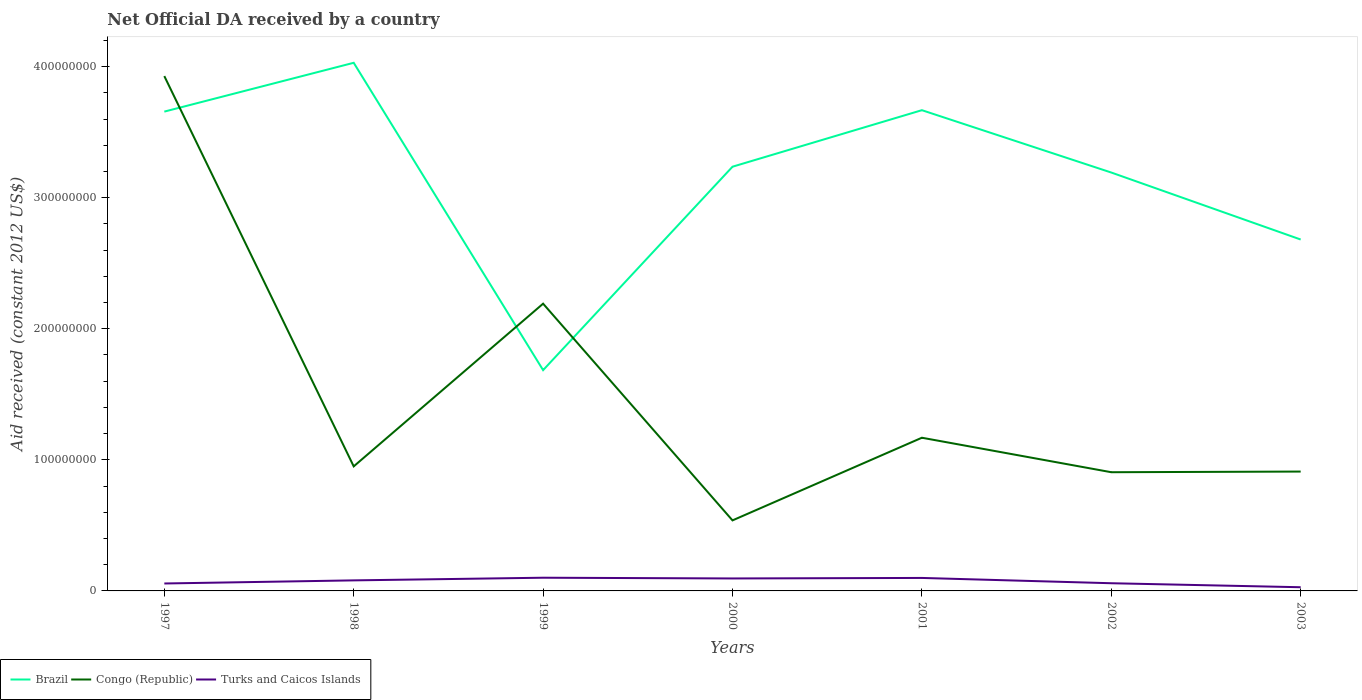How many different coloured lines are there?
Your answer should be compact. 3. Does the line corresponding to Brazil intersect with the line corresponding to Congo (Republic)?
Offer a terse response. Yes. Across all years, what is the maximum net official development assistance aid received in Brazil?
Make the answer very short. 1.68e+08. In which year was the net official development assistance aid received in Congo (Republic) maximum?
Provide a short and direct response. 2000. What is the total net official development assistance aid received in Brazil in the graph?
Keep it short and to the point. 4.65e+07. What is the difference between the highest and the second highest net official development assistance aid received in Brazil?
Offer a very short reply. 2.34e+08. What is the difference between the highest and the lowest net official development assistance aid received in Turks and Caicos Islands?
Offer a terse response. 4. Is the net official development assistance aid received in Congo (Republic) strictly greater than the net official development assistance aid received in Brazil over the years?
Provide a short and direct response. No. How many years are there in the graph?
Provide a short and direct response. 7. How many legend labels are there?
Provide a short and direct response. 3. How are the legend labels stacked?
Your response must be concise. Horizontal. What is the title of the graph?
Your answer should be compact. Net Official DA received by a country. What is the label or title of the Y-axis?
Make the answer very short. Aid received (constant 2012 US$). What is the Aid received (constant 2012 US$) in Brazil in 1997?
Provide a short and direct response. 3.66e+08. What is the Aid received (constant 2012 US$) of Congo (Republic) in 1997?
Give a very brief answer. 3.93e+08. What is the Aid received (constant 2012 US$) in Turks and Caicos Islands in 1997?
Provide a short and direct response. 5.67e+06. What is the Aid received (constant 2012 US$) of Brazil in 1998?
Provide a succinct answer. 4.03e+08. What is the Aid received (constant 2012 US$) in Congo (Republic) in 1998?
Your response must be concise. 9.50e+07. What is the Aid received (constant 2012 US$) in Turks and Caicos Islands in 1998?
Provide a short and direct response. 8.05e+06. What is the Aid received (constant 2012 US$) in Brazil in 1999?
Your answer should be very brief. 1.68e+08. What is the Aid received (constant 2012 US$) of Congo (Republic) in 1999?
Provide a succinct answer. 2.19e+08. What is the Aid received (constant 2012 US$) of Turks and Caicos Islands in 1999?
Offer a very short reply. 1.01e+07. What is the Aid received (constant 2012 US$) in Brazil in 2000?
Give a very brief answer. 3.24e+08. What is the Aid received (constant 2012 US$) of Congo (Republic) in 2000?
Ensure brevity in your answer.  5.38e+07. What is the Aid received (constant 2012 US$) of Turks and Caicos Islands in 2000?
Offer a very short reply. 9.51e+06. What is the Aid received (constant 2012 US$) in Brazil in 2001?
Provide a short and direct response. 3.67e+08. What is the Aid received (constant 2012 US$) in Congo (Republic) in 2001?
Your answer should be very brief. 1.17e+08. What is the Aid received (constant 2012 US$) of Turks and Caicos Islands in 2001?
Your response must be concise. 9.91e+06. What is the Aid received (constant 2012 US$) of Brazil in 2002?
Provide a short and direct response. 3.19e+08. What is the Aid received (constant 2012 US$) of Congo (Republic) in 2002?
Give a very brief answer. 9.06e+07. What is the Aid received (constant 2012 US$) of Turks and Caicos Islands in 2002?
Your answer should be very brief. 5.86e+06. What is the Aid received (constant 2012 US$) of Brazil in 2003?
Your answer should be compact. 2.68e+08. What is the Aid received (constant 2012 US$) in Congo (Republic) in 2003?
Make the answer very short. 9.11e+07. What is the Aid received (constant 2012 US$) of Turks and Caicos Islands in 2003?
Offer a terse response. 2.81e+06. Across all years, what is the maximum Aid received (constant 2012 US$) of Brazil?
Offer a terse response. 4.03e+08. Across all years, what is the maximum Aid received (constant 2012 US$) in Congo (Republic)?
Offer a terse response. 3.93e+08. Across all years, what is the maximum Aid received (constant 2012 US$) in Turks and Caicos Islands?
Make the answer very short. 1.01e+07. Across all years, what is the minimum Aid received (constant 2012 US$) of Brazil?
Your answer should be very brief. 1.68e+08. Across all years, what is the minimum Aid received (constant 2012 US$) of Congo (Republic)?
Your response must be concise. 5.38e+07. Across all years, what is the minimum Aid received (constant 2012 US$) in Turks and Caicos Islands?
Keep it short and to the point. 2.81e+06. What is the total Aid received (constant 2012 US$) in Brazil in the graph?
Offer a terse response. 2.21e+09. What is the total Aid received (constant 2012 US$) of Congo (Republic) in the graph?
Your answer should be compact. 1.06e+09. What is the total Aid received (constant 2012 US$) of Turks and Caicos Islands in the graph?
Offer a terse response. 5.19e+07. What is the difference between the Aid received (constant 2012 US$) in Brazil in 1997 and that in 1998?
Your answer should be compact. -3.72e+07. What is the difference between the Aid received (constant 2012 US$) in Congo (Republic) in 1997 and that in 1998?
Give a very brief answer. 2.98e+08. What is the difference between the Aid received (constant 2012 US$) in Turks and Caicos Islands in 1997 and that in 1998?
Your answer should be very brief. -2.38e+06. What is the difference between the Aid received (constant 2012 US$) of Brazil in 1997 and that in 1999?
Keep it short and to the point. 1.97e+08. What is the difference between the Aid received (constant 2012 US$) of Congo (Republic) in 1997 and that in 1999?
Your answer should be compact. 1.74e+08. What is the difference between the Aid received (constant 2012 US$) in Turks and Caicos Islands in 1997 and that in 1999?
Your response must be concise. -4.40e+06. What is the difference between the Aid received (constant 2012 US$) of Brazil in 1997 and that in 2000?
Ensure brevity in your answer.  4.20e+07. What is the difference between the Aid received (constant 2012 US$) of Congo (Republic) in 1997 and that in 2000?
Ensure brevity in your answer.  3.39e+08. What is the difference between the Aid received (constant 2012 US$) in Turks and Caicos Islands in 1997 and that in 2000?
Offer a terse response. -3.84e+06. What is the difference between the Aid received (constant 2012 US$) in Brazil in 1997 and that in 2001?
Provide a short and direct response. -1.09e+06. What is the difference between the Aid received (constant 2012 US$) in Congo (Republic) in 1997 and that in 2001?
Provide a succinct answer. 2.76e+08. What is the difference between the Aid received (constant 2012 US$) of Turks and Caicos Islands in 1997 and that in 2001?
Provide a succinct answer. -4.24e+06. What is the difference between the Aid received (constant 2012 US$) of Brazil in 1997 and that in 2002?
Your answer should be very brief. 4.65e+07. What is the difference between the Aid received (constant 2012 US$) in Congo (Republic) in 1997 and that in 2002?
Give a very brief answer. 3.02e+08. What is the difference between the Aid received (constant 2012 US$) of Turks and Caicos Islands in 1997 and that in 2002?
Provide a short and direct response. -1.90e+05. What is the difference between the Aid received (constant 2012 US$) in Brazil in 1997 and that in 2003?
Offer a very short reply. 9.76e+07. What is the difference between the Aid received (constant 2012 US$) in Congo (Republic) in 1997 and that in 2003?
Provide a succinct answer. 3.02e+08. What is the difference between the Aid received (constant 2012 US$) in Turks and Caicos Islands in 1997 and that in 2003?
Give a very brief answer. 2.86e+06. What is the difference between the Aid received (constant 2012 US$) of Brazil in 1998 and that in 1999?
Offer a terse response. 2.34e+08. What is the difference between the Aid received (constant 2012 US$) of Congo (Republic) in 1998 and that in 1999?
Provide a succinct answer. -1.24e+08. What is the difference between the Aid received (constant 2012 US$) of Turks and Caicos Islands in 1998 and that in 1999?
Ensure brevity in your answer.  -2.02e+06. What is the difference between the Aid received (constant 2012 US$) in Brazil in 1998 and that in 2000?
Your answer should be very brief. 7.93e+07. What is the difference between the Aid received (constant 2012 US$) in Congo (Republic) in 1998 and that in 2000?
Your response must be concise. 4.12e+07. What is the difference between the Aid received (constant 2012 US$) in Turks and Caicos Islands in 1998 and that in 2000?
Your answer should be compact. -1.46e+06. What is the difference between the Aid received (constant 2012 US$) in Brazil in 1998 and that in 2001?
Provide a short and direct response. 3.62e+07. What is the difference between the Aid received (constant 2012 US$) in Congo (Republic) in 1998 and that in 2001?
Make the answer very short. -2.18e+07. What is the difference between the Aid received (constant 2012 US$) in Turks and Caicos Islands in 1998 and that in 2001?
Your answer should be compact. -1.86e+06. What is the difference between the Aid received (constant 2012 US$) in Brazil in 1998 and that in 2002?
Offer a terse response. 8.37e+07. What is the difference between the Aid received (constant 2012 US$) in Congo (Republic) in 1998 and that in 2002?
Keep it short and to the point. 4.46e+06. What is the difference between the Aid received (constant 2012 US$) in Turks and Caicos Islands in 1998 and that in 2002?
Offer a very short reply. 2.19e+06. What is the difference between the Aid received (constant 2012 US$) of Brazil in 1998 and that in 2003?
Make the answer very short. 1.35e+08. What is the difference between the Aid received (constant 2012 US$) of Congo (Republic) in 1998 and that in 2003?
Keep it short and to the point. 3.96e+06. What is the difference between the Aid received (constant 2012 US$) of Turks and Caicos Islands in 1998 and that in 2003?
Your response must be concise. 5.24e+06. What is the difference between the Aid received (constant 2012 US$) of Brazil in 1999 and that in 2000?
Keep it short and to the point. -1.55e+08. What is the difference between the Aid received (constant 2012 US$) in Congo (Republic) in 1999 and that in 2000?
Offer a very short reply. 1.65e+08. What is the difference between the Aid received (constant 2012 US$) of Turks and Caicos Islands in 1999 and that in 2000?
Give a very brief answer. 5.60e+05. What is the difference between the Aid received (constant 2012 US$) in Brazil in 1999 and that in 2001?
Your answer should be very brief. -1.98e+08. What is the difference between the Aid received (constant 2012 US$) in Congo (Republic) in 1999 and that in 2001?
Your response must be concise. 1.02e+08. What is the difference between the Aid received (constant 2012 US$) in Turks and Caicos Islands in 1999 and that in 2001?
Give a very brief answer. 1.60e+05. What is the difference between the Aid received (constant 2012 US$) of Brazil in 1999 and that in 2002?
Keep it short and to the point. -1.51e+08. What is the difference between the Aid received (constant 2012 US$) in Congo (Republic) in 1999 and that in 2002?
Give a very brief answer. 1.29e+08. What is the difference between the Aid received (constant 2012 US$) in Turks and Caicos Islands in 1999 and that in 2002?
Give a very brief answer. 4.21e+06. What is the difference between the Aid received (constant 2012 US$) of Brazil in 1999 and that in 2003?
Your response must be concise. -9.97e+07. What is the difference between the Aid received (constant 2012 US$) of Congo (Republic) in 1999 and that in 2003?
Make the answer very short. 1.28e+08. What is the difference between the Aid received (constant 2012 US$) of Turks and Caicos Islands in 1999 and that in 2003?
Provide a short and direct response. 7.26e+06. What is the difference between the Aid received (constant 2012 US$) of Brazil in 2000 and that in 2001?
Ensure brevity in your answer.  -4.31e+07. What is the difference between the Aid received (constant 2012 US$) of Congo (Republic) in 2000 and that in 2001?
Offer a very short reply. -6.31e+07. What is the difference between the Aid received (constant 2012 US$) in Turks and Caicos Islands in 2000 and that in 2001?
Offer a very short reply. -4.00e+05. What is the difference between the Aid received (constant 2012 US$) in Brazil in 2000 and that in 2002?
Provide a succinct answer. 4.44e+06. What is the difference between the Aid received (constant 2012 US$) in Congo (Republic) in 2000 and that in 2002?
Keep it short and to the point. -3.68e+07. What is the difference between the Aid received (constant 2012 US$) of Turks and Caicos Islands in 2000 and that in 2002?
Offer a terse response. 3.65e+06. What is the difference between the Aid received (constant 2012 US$) in Brazil in 2000 and that in 2003?
Ensure brevity in your answer.  5.56e+07. What is the difference between the Aid received (constant 2012 US$) in Congo (Republic) in 2000 and that in 2003?
Provide a succinct answer. -3.72e+07. What is the difference between the Aid received (constant 2012 US$) in Turks and Caicos Islands in 2000 and that in 2003?
Ensure brevity in your answer.  6.70e+06. What is the difference between the Aid received (constant 2012 US$) of Brazil in 2001 and that in 2002?
Offer a terse response. 4.76e+07. What is the difference between the Aid received (constant 2012 US$) of Congo (Republic) in 2001 and that in 2002?
Your response must be concise. 2.63e+07. What is the difference between the Aid received (constant 2012 US$) of Turks and Caicos Islands in 2001 and that in 2002?
Make the answer very short. 4.05e+06. What is the difference between the Aid received (constant 2012 US$) of Brazil in 2001 and that in 2003?
Provide a succinct answer. 9.87e+07. What is the difference between the Aid received (constant 2012 US$) of Congo (Republic) in 2001 and that in 2003?
Provide a succinct answer. 2.58e+07. What is the difference between the Aid received (constant 2012 US$) of Turks and Caicos Islands in 2001 and that in 2003?
Your response must be concise. 7.10e+06. What is the difference between the Aid received (constant 2012 US$) in Brazil in 2002 and that in 2003?
Provide a short and direct response. 5.11e+07. What is the difference between the Aid received (constant 2012 US$) of Congo (Republic) in 2002 and that in 2003?
Offer a terse response. -5.00e+05. What is the difference between the Aid received (constant 2012 US$) in Turks and Caicos Islands in 2002 and that in 2003?
Make the answer very short. 3.05e+06. What is the difference between the Aid received (constant 2012 US$) in Brazil in 1997 and the Aid received (constant 2012 US$) in Congo (Republic) in 1998?
Your answer should be compact. 2.71e+08. What is the difference between the Aid received (constant 2012 US$) of Brazil in 1997 and the Aid received (constant 2012 US$) of Turks and Caicos Islands in 1998?
Offer a very short reply. 3.58e+08. What is the difference between the Aid received (constant 2012 US$) in Congo (Republic) in 1997 and the Aid received (constant 2012 US$) in Turks and Caicos Islands in 1998?
Your answer should be compact. 3.85e+08. What is the difference between the Aid received (constant 2012 US$) of Brazil in 1997 and the Aid received (constant 2012 US$) of Congo (Republic) in 1999?
Offer a terse response. 1.47e+08. What is the difference between the Aid received (constant 2012 US$) of Brazil in 1997 and the Aid received (constant 2012 US$) of Turks and Caicos Islands in 1999?
Provide a succinct answer. 3.56e+08. What is the difference between the Aid received (constant 2012 US$) in Congo (Republic) in 1997 and the Aid received (constant 2012 US$) in Turks and Caicos Islands in 1999?
Ensure brevity in your answer.  3.83e+08. What is the difference between the Aid received (constant 2012 US$) of Brazil in 1997 and the Aid received (constant 2012 US$) of Congo (Republic) in 2000?
Offer a very short reply. 3.12e+08. What is the difference between the Aid received (constant 2012 US$) in Brazil in 1997 and the Aid received (constant 2012 US$) in Turks and Caicos Islands in 2000?
Offer a very short reply. 3.56e+08. What is the difference between the Aid received (constant 2012 US$) in Congo (Republic) in 1997 and the Aid received (constant 2012 US$) in Turks and Caicos Islands in 2000?
Your answer should be very brief. 3.83e+08. What is the difference between the Aid received (constant 2012 US$) in Brazil in 1997 and the Aid received (constant 2012 US$) in Congo (Republic) in 2001?
Provide a succinct answer. 2.49e+08. What is the difference between the Aid received (constant 2012 US$) of Brazil in 1997 and the Aid received (constant 2012 US$) of Turks and Caicos Islands in 2001?
Ensure brevity in your answer.  3.56e+08. What is the difference between the Aid received (constant 2012 US$) in Congo (Republic) in 1997 and the Aid received (constant 2012 US$) in Turks and Caicos Islands in 2001?
Your answer should be compact. 3.83e+08. What is the difference between the Aid received (constant 2012 US$) of Brazil in 1997 and the Aid received (constant 2012 US$) of Congo (Republic) in 2002?
Offer a terse response. 2.75e+08. What is the difference between the Aid received (constant 2012 US$) in Brazil in 1997 and the Aid received (constant 2012 US$) in Turks and Caicos Islands in 2002?
Make the answer very short. 3.60e+08. What is the difference between the Aid received (constant 2012 US$) in Congo (Republic) in 1997 and the Aid received (constant 2012 US$) in Turks and Caicos Islands in 2002?
Keep it short and to the point. 3.87e+08. What is the difference between the Aid received (constant 2012 US$) of Brazil in 1997 and the Aid received (constant 2012 US$) of Congo (Republic) in 2003?
Your answer should be compact. 2.75e+08. What is the difference between the Aid received (constant 2012 US$) of Brazil in 1997 and the Aid received (constant 2012 US$) of Turks and Caicos Islands in 2003?
Provide a short and direct response. 3.63e+08. What is the difference between the Aid received (constant 2012 US$) in Congo (Republic) in 1997 and the Aid received (constant 2012 US$) in Turks and Caicos Islands in 2003?
Make the answer very short. 3.90e+08. What is the difference between the Aid received (constant 2012 US$) of Brazil in 1998 and the Aid received (constant 2012 US$) of Congo (Republic) in 1999?
Your response must be concise. 1.84e+08. What is the difference between the Aid received (constant 2012 US$) in Brazil in 1998 and the Aid received (constant 2012 US$) in Turks and Caicos Islands in 1999?
Provide a short and direct response. 3.93e+08. What is the difference between the Aid received (constant 2012 US$) in Congo (Republic) in 1998 and the Aid received (constant 2012 US$) in Turks and Caicos Islands in 1999?
Ensure brevity in your answer.  8.50e+07. What is the difference between the Aid received (constant 2012 US$) of Brazil in 1998 and the Aid received (constant 2012 US$) of Congo (Republic) in 2000?
Your answer should be compact. 3.49e+08. What is the difference between the Aid received (constant 2012 US$) in Brazil in 1998 and the Aid received (constant 2012 US$) in Turks and Caicos Islands in 2000?
Your answer should be very brief. 3.93e+08. What is the difference between the Aid received (constant 2012 US$) in Congo (Republic) in 1998 and the Aid received (constant 2012 US$) in Turks and Caicos Islands in 2000?
Your response must be concise. 8.55e+07. What is the difference between the Aid received (constant 2012 US$) in Brazil in 1998 and the Aid received (constant 2012 US$) in Congo (Republic) in 2001?
Your answer should be very brief. 2.86e+08. What is the difference between the Aid received (constant 2012 US$) of Brazil in 1998 and the Aid received (constant 2012 US$) of Turks and Caicos Islands in 2001?
Your response must be concise. 3.93e+08. What is the difference between the Aid received (constant 2012 US$) in Congo (Republic) in 1998 and the Aid received (constant 2012 US$) in Turks and Caicos Islands in 2001?
Offer a terse response. 8.51e+07. What is the difference between the Aid received (constant 2012 US$) in Brazil in 1998 and the Aid received (constant 2012 US$) in Congo (Republic) in 2002?
Provide a short and direct response. 3.12e+08. What is the difference between the Aid received (constant 2012 US$) in Brazil in 1998 and the Aid received (constant 2012 US$) in Turks and Caicos Islands in 2002?
Offer a very short reply. 3.97e+08. What is the difference between the Aid received (constant 2012 US$) of Congo (Republic) in 1998 and the Aid received (constant 2012 US$) of Turks and Caicos Islands in 2002?
Provide a succinct answer. 8.92e+07. What is the difference between the Aid received (constant 2012 US$) of Brazil in 1998 and the Aid received (constant 2012 US$) of Congo (Republic) in 2003?
Give a very brief answer. 3.12e+08. What is the difference between the Aid received (constant 2012 US$) of Brazil in 1998 and the Aid received (constant 2012 US$) of Turks and Caicos Islands in 2003?
Your answer should be compact. 4.00e+08. What is the difference between the Aid received (constant 2012 US$) in Congo (Republic) in 1998 and the Aid received (constant 2012 US$) in Turks and Caicos Islands in 2003?
Your answer should be very brief. 9.22e+07. What is the difference between the Aid received (constant 2012 US$) in Brazil in 1999 and the Aid received (constant 2012 US$) in Congo (Republic) in 2000?
Offer a terse response. 1.15e+08. What is the difference between the Aid received (constant 2012 US$) in Brazil in 1999 and the Aid received (constant 2012 US$) in Turks and Caicos Islands in 2000?
Offer a terse response. 1.59e+08. What is the difference between the Aid received (constant 2012 US$) in Congo (Republic) in 1999 and the Aid received (constant 2012 US$) in Turks and Caicos Islands in 2000?
Provide a short and direct response. 2.10e+08. What is the difference between the Aid received (constant 2012 US$) of Brazil in 1999 and the Aid received (constant 2012 US$) of Congo (Republic) in 2001?
Provide a succinct answer. 5.16e+07. What is the difference between the Aid received (constant 2012 US$) of Brazil in 1999 and the Aid received (constant 2012 US$) of Turks and Caicos Islands in 2001?
Provide a succinct answer. 1.59e+08. What is the difference between the Aid received (constant 2012 US$) in Congo (Republic) in 1999 and the Aid received (constant 2012 US$) in Turks and Caicos Islands in 2001?
Give a very brief answer. 2.09e+08. What is the difference between the Aid received (constant 2012 US$) of Brazil in 1999 and the Aid received (constant 2012 US$) of Congo (Republic) in 2002?
Make the answer very short. 7.79e+07. What is the difference between the Aid received (constant 2012 US$) of Brazil in 1999 and the Aid received (constant 2012 US$) of Turks and Caicos Islands in 2002?
Provide a succinct answer. 1.63e+08. What is the difference between the Aid received (constant 2012 US$) in Congo (Republic) in 1999 and the Aid received (constant 2012 US$) in Turks and Caicos Islands in 2002?
Your answer should be very brief. 2.13e+08. What is the difference between the Aid received (constant 2012 US$) in Brazil in 1999 and the Aid received (constant 2012 US$) in Congo (Republic) in 2003?
Provide a succinct answer. 7.74e+07. What is the difference between the Aid received (constant 2012 US$) of Brazil in 1999 and the Aid received (constant 2012 US$) of Turks and Caicos Islands in 2003?
Keep it short and to the point. 1.66e+08. What is the difference between the Aid received (constant 2012 US$) of Congo (Republic) in 1999 and the Aid received (constant 2012 US$) of Turks and Caicos Islands in 2003?
Offer a very short reply. 2.16e+08. What is the difference between the Aid received (constant 2012 US$) of Brazil in 2000 and the Aid received (constant 2012 US$) of Congo (Republic) in 2001?
Offer a terse response. 2.07e+08. What is the difference between the Aid received (constant 2012 US$) of Brazil in 2000 and the Aid received (constant 2012 US$) of Turks and Caicos Islands in 2001?
Make the answer very short. 3.14e+08. What is the difference between the Aid received (constant 2012 US$) in Congo (Republic) in 2000 and the Aid received (constant 2012 US$) in Turks and Caicos Islands in 2001?
Keep it short and to the point. 4.39e+07. What is the difference between the Aid received (constant 2012 US$) in Brazil in 2000 and the Aid received (constant 2012 US$) in Congo (Republic) in 2002?
Your response must be concise. 2.33e+08. What is the difference between the Aid received (constant 2012 US$) in Brazil in 2000 and the Aid received (constant 2012 US$) in Turks and Caicos Islands in 2002?
Make the answer very short. 3.18e+08. What is the difference between the Aid received (constant 2012 US$) of Congo (Republic) in 2000 and the Aid received (constant 2012 US$) of Turks and Caicos Islands in 2002?
Give a very brief answer. 4.80e+07. What is the difference between the Aid received (constant 2012 US$) in Brazil in 2000 and the Aid received (constant 2012 US$) in Congo (Republic) in 2003?
Provide a succinct answer. 2.33e+08. What is the difference between the Aid received (constant 2012 US$) of Brazil in 2000 and the Aid received (constant 2012 US$) of Turks and Caicos Islands in 2003?
Offer a terse response. 3.21e+08. What is the difference between the Aid received (constant 2012 US$) of Congo (Republic) in 2000 and the Aid received (constant 2012 US$) of Turks and Caicos Islands in 2003?
Provide a short and direct response. 5.10e+07. What is the difference between the Aid received (constant 2012 US$) in Brazil in 2001 and the Aid received (constant 2012 US$) in Congo (Republic) in 2002?
Make the answer very short. 2.76e+08. What is the difference between the Aid received (constant 2012 US$) in Brazil in 2001 and the Aid received (constant 2012 US$) in Turks and Caicos Islands in 2002?
Provide a succinct answer. 3.61e+08. What is the difference between the Aid received (constant 2012 US$) in Congo (Republic) in 2001 and the Aid received (constant 2012 US$) in Turks and Caicos Islands in 2002?
Offer a very short reply. 1.11e+08. What is the difference between the Aid received (constant 2012 US$) in Brazil in 2001 and the Aid received (constant 2012 US$) in Congo (Republic) in 2003?
Offer a very short reply. 2.76e+08. What is the difference between the Aid received (constant 2012 US$) in Brazil in 2001 and the Aid received (constant 2012 US$) in Turks and Caicos Islands in 2003?
Offer a terse response. 3.64e+08. What is the difference between the Aid received (constant 2012 US$) in Congo (Republic) in 2001 and the Aid received (constant 2012 US$) in Turks and Caicos Islands in 2003?
Ensure brevity in your answer.  1.14e+08. What is the difference between the Aid received (constant 2012 US$) of Brazil in 2002 and the Aid received (constant 2012 US$) of Congo (Republic) in 2003?
Your answer should be compact. 2.28e+08. What is the difference between the Aid received (constant 2012 US$) of Brazil in 2002 and the Aid received (constant 2012 US$) of Turks and Caicos Islands in 2003?
Offer a very short reply. 3.16e+08. What is the difference between the Aid received (constant 2012 US$) of Congo (Republic) in 2002 and the Aid received (constant 2012 US$) of Turks and Caicos Islands in 2003?
Your answer should be very brief. 8.78e+07. What is the average Aid received (constant 2012 US$) in Brazil per year?
Keep it short and to the point. 3.16e+08. What is the average Aid received (constant 2012 US$) in Congo (Republic) per year?
Your answer should be very brief. 1.51e+08. What is the average Aid received (constant 2012 US$) in Turks and Caicos Islands per year?
Provide a succinct answer. 7.41e+06. In the year 1997, what is the difference between the Aid received (constant 2012 US$) in Brazil and Aid received (constant 2012 US$) in Congo (Republic)?
Your response must be concise. -2.71e+07. In the year 1997, what is the difference between the Aid received (constant 2012 US$) in Brazil and Aid received (constant 2012 US$) in Turks and Caicos Islands?
Give a very brief answer. 3.60e+08. In the year 1997, what is the difference between the Aid received (constant 2012 US$) in Congo (Republic) and Aid received (constant 2012 US$) in Turks and Caicos Islands?
Your answer should be very brief. 3.87e+08. In the year 1998, what is the difference between the Aid received (constant 2012 US$) in Brazil and Aid received (constant 2012 US$) in Congo (Republic)?
Provide a short and direct response. 3.08e+08. In the year 1998, what is the difference between the Aid received (constant 2012 US$) of Brazil and Aid received (constant 2012 US$) of Turks and Caicos Islands?
Ensure brevity in your answer.  3.95e+08. In the year 1998, what is the difference between the Aid received (constant 2012 US$) of Congo (Republic) and Aid received (constant 2012 US$) of Turks and Caicos Islands?
Offer a very short reply. 8.70e+07. In the year 1999, what is the difference between the Aid received (constant 2012 US$) of Brazil and Aid received (constant 2012 US$) of Congo (Republic)?
Your response must be concise. -5.07e+07. In the year 1999, what is the difference between the Aid received (constant 2012 US$) of Brazil and Aid received (constant 2012 US$) of Turks and Caicos Islands?
Your answer should be compact. 1.58e+08. In the year 1999, what is the difference between the Aid received (constant 2012 US$) in Congo (Republic) and Aid received (constant 2012 US$) in Turks and Caicos Islands?
Make the answer very short. 2.09e+08. In the year 2000, what is the difference between the Aid received (constant 2012 US$) of Brazil and Aid received (constant 2012 US$) of Congo (Republic)?
Your answer should be very brief. 2.70e+08. In the year 2000, what is the difference between the Aid received (constant 2012 US$) in Brazil and Aid received (constant 2012 US$) in Turks and Caicos Islands?
Make the answer very short. 3.14e+08. In the year 2000, what is the difference between the Aid received (constant 2012 US$) of Congo (Republic) and Aid received (constant 2012 US$) of Turks and Caicos Islands?
Make the answer very short. 4.43e+07. In the year 2001, what is the difference between the Aid received (constant 2012 US$) of Brazil and Aid received (constant 2012 US$) of Congo (Republic)?
Your response must be concise. 2.50e+08. In the year 2001, what is the difference between the Aid received (constant 2012 US$) in Brazil and Aid received (constant 2012 US$) in Turks and Caicos Islands?
Your response must be concise. 3.57e+08. In the year 2001, what is the difference between the Aid received (constant 2012 US$) in Congo (Republic) and Aid received (constant 2012 US$) in Turks and Caicos Islands?
Your answer should be compact. 1.07e+08. In the year 2002, what is the difference between the Aid received (constant 2012 US$) of Brazil and Aid received (constant 2012 US$) of Congo (Republic)?
Keep it short and to the point. 2.29e+08. In the year 2002, what is the difference between the Aid received (constant 2012 US$) of Brazil and Aid received (constant 2012 US$) of Turks and Caicos Islands?
Make the answer very short. 3.13e+08. In the year 2002, what is the difference between the Aid received (constant 2012 US$) of Congo (Republic) and Aid received (constant 2012 US$) of Turks and Caicos Islands?
Give a very brief answer. 8.47e+07. In the year 2003, what is the difference between the Aid received (constant 2012 US$) of Brazil and Aid received (constant 2012 US$) of Congo (Republic)?
Provide a succinct answer. 1.77e+08. In the year 2003, what is the difference between the Aid received (constant 2012 US$) of Brazil and Aid received (constant 2012 US$) of Turks and Caicos Islands?
Provide a succinct answer. 2.65e+08. In the year 2003, what is the difference between the Aid received (constant 2012 US$) of Congo (Republic) and Aid received (constant 2012 US$) of Turks and Caicos Islands?
Provide a succinct answer. 8.82e+07. What is the ratio of the Aid received (constant 2012 US$) of Brazil in 1997 to that in 1998?
Provide a succinct answer. 0.91. What is the ratio of the Aid received (constant 2012 US$) of Congo (Republic) in 1997 to that in 1998?
Give a very brief answer. 4.13. What is the ratio of the Aid received (constant 2012 US$) in Turks and Caicos Islands in 1997 to that in 1998?
Provide a short and direct response. 0.7. What is the ratio of the Aid received (constant 2012 US$) in Brazil in 1997 to that in 1999?
Keep it short and to the point. 2.17. What is the ratio of the Aid received (constant 2012 US$) of Congo (Republic) in 1997 to that in 1999?
Provide a short and direct response. 1.79. What is the ratio of the Aid received (constant 2012 US$) in Turks and Caicos Islands in 1997 to that in 1999?
Your answer should be compact. 0.56. What is the ratio of the Aid received (constant 2012 US$) in Brazil in 1997 to that in 2000?
Your answer should be very brief. 1.13. What is the ratio of the Aid received (constant 2012 US$) in Congo (Republic) in 1997 to that in 2000?
Your response must be concise. 7.3. What is the ratio of the Aid received (constant 2012 US$) of Turks and Caicos Islands in 1997 to that in 2000?
Provide a short and direct response. 0.6. What is the ratio of the Aid received (constant 2012 US$) in Brazil in 1997 to that in 2001?
Give a very brief answer. 1. What is the ratio of the Aid received (constant 2012 US$) of Congo (Republic) in 1997 to that in 2001?
Provide a short and direct response. 3.36. What is the ratio of the Aid received (constant 2012 US$) of Turks and Caicos Islands in 1997 to that in 2001?
Your answer should be compact. 0.57. What is the ratio of the Aid received (constant 2012 US$) in Brazil in 1997 to that in 2002?
Your answer should be very brief. 1.15. What is the ratio of the Aid received (constant 2012 US$) of Congo (Republic) in 1997 to that in 2002?
Your answer should be very brief. 4.34. What is the ratio of the Aid received (constant 2012 US$) of Turks and Caicos Islands in 1997 to that in 2002?
Provide a succinct answer. 0.97. What is the ratio of the Aid received (constant 2012 US$) of Brazil in 1997 to that in 2003?
Give a very brief answer. 1.36. What is the ratio of the Aid received (constant 2012 US$) of Congo (Republic) in 1997 to that in 2003?
Give a very brief answer. 4.31. What is the ratio of the Aid received (constant 2012 US$) in Turks and Caicos Islands in 1997 to that in 2003?
Your answer should be compact. 2.02. What is the ratio of the Aid received (constant 2012 US$) in Brazil in 1998 to that in 1999?
Provide a short and direct response. 2.39. What is the ratio of the Aid received (constant 2012 US$) in Congo (Republic) in 1998 to that in 1999?
Provide a short and direct response. 0.43. What is the ratio of the Aid received (constant 2012 US$) in Turks and Caicos Islands in 1998 to that in 1999?
Give a very brief answer. 0.8. What is the ratio of the Aid received (constant 2012 US$) in Brazil in 1998 to that in 2000?
Keep it short and to the point. 1.25. What is the ratio of the Aid received (constant 2012 US$) in Congo (Republic) in 1998 to that in 2000?
Give a very brief answer. 1.77. What is the ratio of the Aid received (constant 2012 US$) in Turks and Caicos Islands in 1998 to that in 2000?
Your answer should be compact. 0.85. What is the ratio of the Aid received (constant 2012 US$) of Brazil in 1998 to that in 2001?
Ensure brevity in your answer.  1.1. What is the ratio of the Aid received (constant 2012 US$) in Congo (Republic) in 1998 to that in 2001?
Your answer should be compact. 0.81. What is the ratio of the Aid received (constant 2012 US$) of Turks and Caicos Islands in 1998 to that in 2001?
Your answer should be compact. 0.81. What is the ratio of the Aid received (constant 2012 US$) in Brazil in 1998 to that in 2002?
Make the answer very short. 1.26. What is the ratio of the Aid received (constant 2012 US$) of Congo (Republic) in 1998 to that in 2002?
Provide a succinct answer. 1.05. What is the ratio of the Aid received (constant 2012 US$) in Turks and Caicos Islands in 1998 to that in 2002?
Ensure brevity in your answer.  1.37. What is the ratio of the Aid received (constant 2012 US$) of Brazil in 1998 to that in 2003?
Offer a terse response. 1.5. What is the ratio of the Aid received (constant 2012 US$) of Congo (Republic) in 1998 to that in 2003?
Keep it short and to the point. 1.04. What is the ratio of the Aid received (constant 2012 US$) of Turks and Caicos Islands in 1998 to that in 2003?
Offer a very short reply. 2.86. What is the ratio of the Aid received (constant 2012 US$) in Brazil in 1999 to that in 2000?
Offer a very short reply. 0.52. What is the ratio of the Aid received (constant 2012 US$) in Congo (Republic) in 1999 to that in 2000?
Ensure brevity in your answer.  4.07. What is the ratio of the Aid received (constant 2012 US$) in Turks and Caicos Islands in 1999 to that in 2000?
Your answer should be compact. 1.06. What is the ratio of the Aid received (constant 2012 US$) in Brazil in 1999 to that in 2001?
Ensure brevity in your answer.  0.46. What is the ratio of the Aid received (constant 2012 US$) in Congo (Republic) in 1999 to that in 2001?
Make the answer very short. 1.88. What is the ratio of the Aid received (constant 2012 US$) in Turks and Caicos Islands in 1999 to that in 2001?
Your answer should be very brief. 1.02. What is the ratio of the Aid received (constant 2012 US$) of Brazil in 1999 to that in 2002?
Provide a short and direct response. 0.53. What is the ratio of the Aid received (constant 2012 US$) in Congo (Republic) in 1999 to that in 2002?
Give a very brief answer. 2.42. What is the ratio of the Aid received (constant 2012 US$) of Turks and Caicos Islands in 1999 to that in 2002?
Ensure brevity in your answer.  1.72. What is the ratio of the Aid received (constant 2012 US$) in Brazil in 1999 to that in 2003?
Your answer should be compact. 0.63. What is the ratio of the Aid received (constant 2012 US$) in Congo (Republic) in 1999 to that in 2003?
Give a very brief answer. 2.41. What is the ratio of the Aid received (constant 2012 US$) of Turks and Caicos Islands in 1999 to that in 2003?
Provide a short and direct response. 3.58. What is the ratio of the Aid received (constant 2012 US$) of Brazil in 2000 to that in 2001?
Offer a very short reply. 0.88. What is the ratio of the Aid received (constant 2012 US$) of Congo (Republic) in 2000 to that in 2001?
Keep it short and to the point. 0.46. What is the ratio of the Aid received (constant 2012 US$) of Turks and Caicos Islands in 2000 to that in 2001?
Your response must be concise. 0.96. What is the ratio of the Aid received (constant 2012 US$) in Brazil in 2000 to that in 2002?
Your answer should be compact. 1.01. What is the ratio of the Aid received (constant 2012 US$) of Congo (Republic) in 2000 to that in 2002?
Provide a succinct answer. 0.59. What is the ratio of the Aid received (constant 2012 US$) in Turks and Caicos Islands in 2000 to that in 2002?
Keep it short and to the point. 1.62. What is the ratio of the Aid received (constant 2012 US$) of Brazil in 2000 to that in 2003?
Your answer should be compact. 1.21. What is the ratio of the Aid received (constant 2012 US$) of Congo (Republic) in 2000 to that in 2003?
Offer a very short reply. 0.59. What is the ratio of the Aid received (constant 2012 US$) in Turks and Caicos Islands in 2000 to that in 2003?
Offer a terse response. 3.38. What is the ratio of the Aid received (constant 2012 US$) of Brazil in 2001 to that in 2002?
Offer a very short reply. 1.15. What is the ratio of the Aid received (constant 2012 US$) in Congo (Republic) in 2001 to that in 2002?
Provide a succinct answer. 1.29. What is the ratio of the Aid received (constant 2012 US$) in Turks and Caicos Islands in 2001 to that in 2002?
Your answer should be compact. 1.69. What is the ratio of the Aid received (constant 2012 US$) in Brazil in 2001 to that in 2003?
Ensure brevity in your answer.  1.37. What is the ratio of the Aid received (constant 2012 US$) of Congo (Republic) in 2001 to that in 2003?
Make the answer very short. 1.28. What is the ratio of the Aid received (constant 2012 US$) of Turks and Caicos Islands in 2001 to that in 2003?
Provide a succinct answer. 3.53. What is the ratio of the Aid received (constant 2012 US$) in Brazil in 2002 to that in 2003?
Provide a succinct answer. 1.19. What is the ratio of the Aid received (constant 2012 US$) of Congo (Republic) in 2002 to that in 2003?
Make the answer very short. 0.99. What is the ratio of the Aid received (constant 2012 US$) in Turks and Caicos Islands in 2002 to that in 2003?
Keep it short and to the point. 2.09. What is the difference between the highest and the second highest Aid received (constant 2012 US$) in Brazil?
Make the answer very short. 3.62e+07. What is the difference between the highest and the second highest Aid received (constant 2012 US$) in Congo (Republic)?
Make the answer very short. 1.74e+08. What is the difference between the highest and the second highest Aid received (constant 2012 US$) of Turks and Caicos Islands?
Make the answer very short. 1.60e+05. What is the difference between the highest and the lowest Aid received (constant 2012 US$) of Brazil?
Give a very brief answer. 2.34e+08. What is the difference between the highest and the lowest Aid received (constant 2012 US$) in Congo (Republic)?
Your response must be concise. 3.39e+08. What is the difference between the highest and the lowest Aid received (constant 2012 US$) of Turks and Caicos Islands?
Make the answer very short. 7.26e+06. 